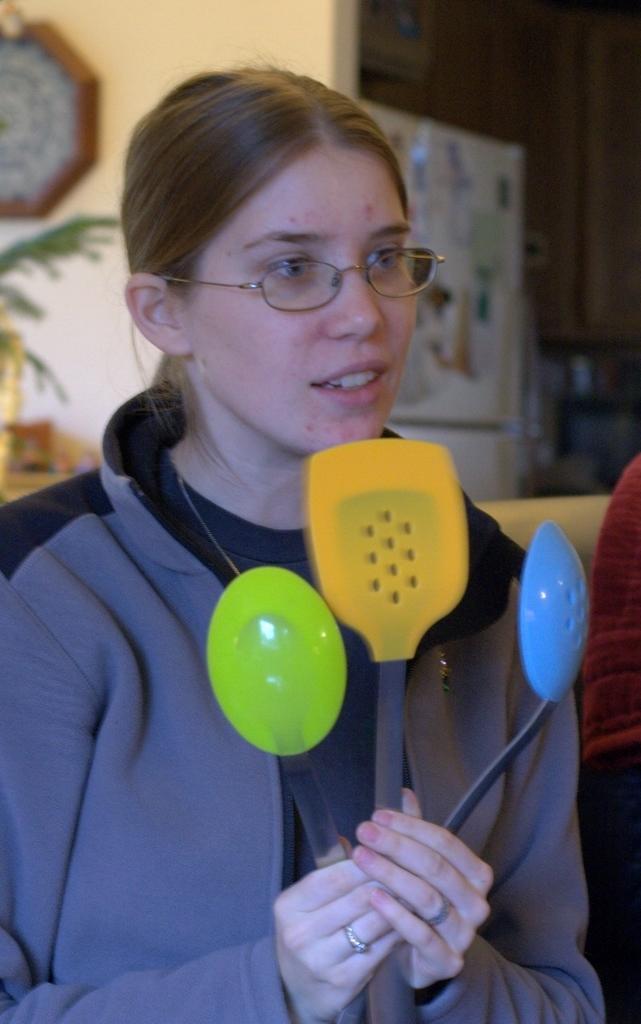Please provide a concise description of this image. In this image I can see a woman holding colorful spatulas and her mouth is open , in the background I can see the wall , on the wall I can see the clock and I can see a leaf. 